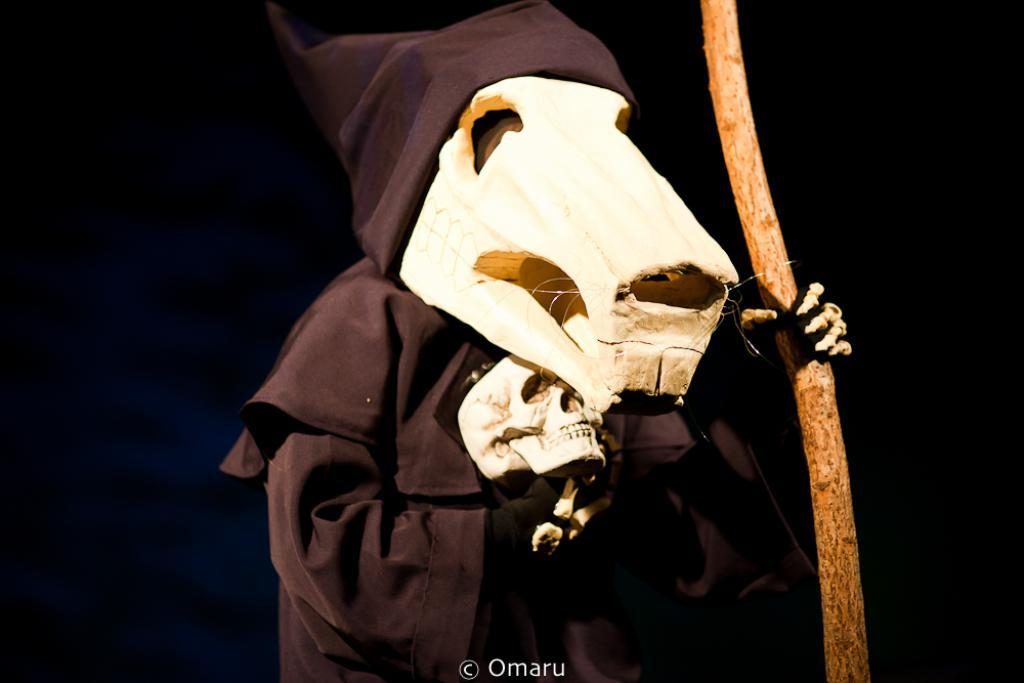What is the main subject of the image? There is a person in the image. What is the person wearing? The person is wearing a fancy dress and a mask. What can be observed about the background of the image? The background of the image is dark. What type of acoustics can be heard in the image? There is no information about sound or acoustics in the image, so it cannot be determined. 